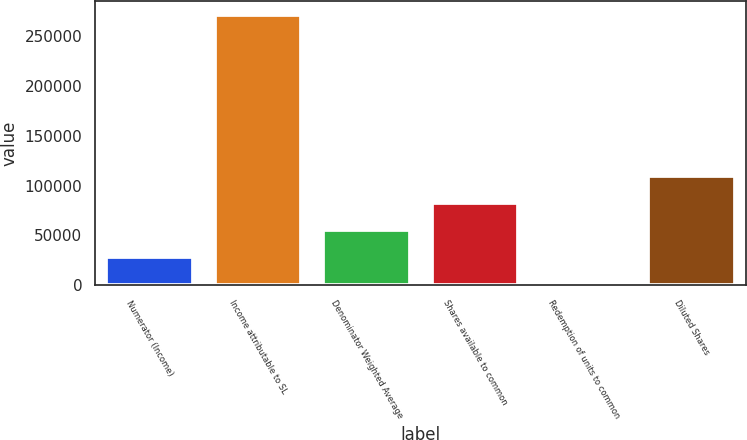Convert chart. <chart><loc_0><loc_0><loc_500><loc_500><bar_chart><fcel>Numerator (Income)<fcel>Income attributable to SL<fcel>Denominator Weighted Average<fcel>Shares available to common<fcel>Redemption of units to common<fcel>Diluted Shares<nl><fcel>28271.5<fcel>270826<fcel>55222<fcel>82172.5<fcel>1321<fcel>109123<nl></chart> 